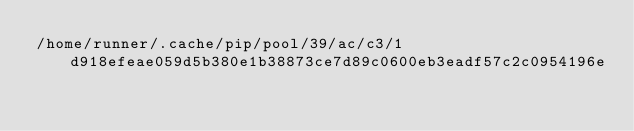<code> <loc_0><loc_0><loc_500><loc_500><_Python_>/home/runner/.cache/pip/pool/39/ac/c3/1d918efeae059d5b380e1b38873ce7d89c0600eb3eadf57c2c0954196e</code> 